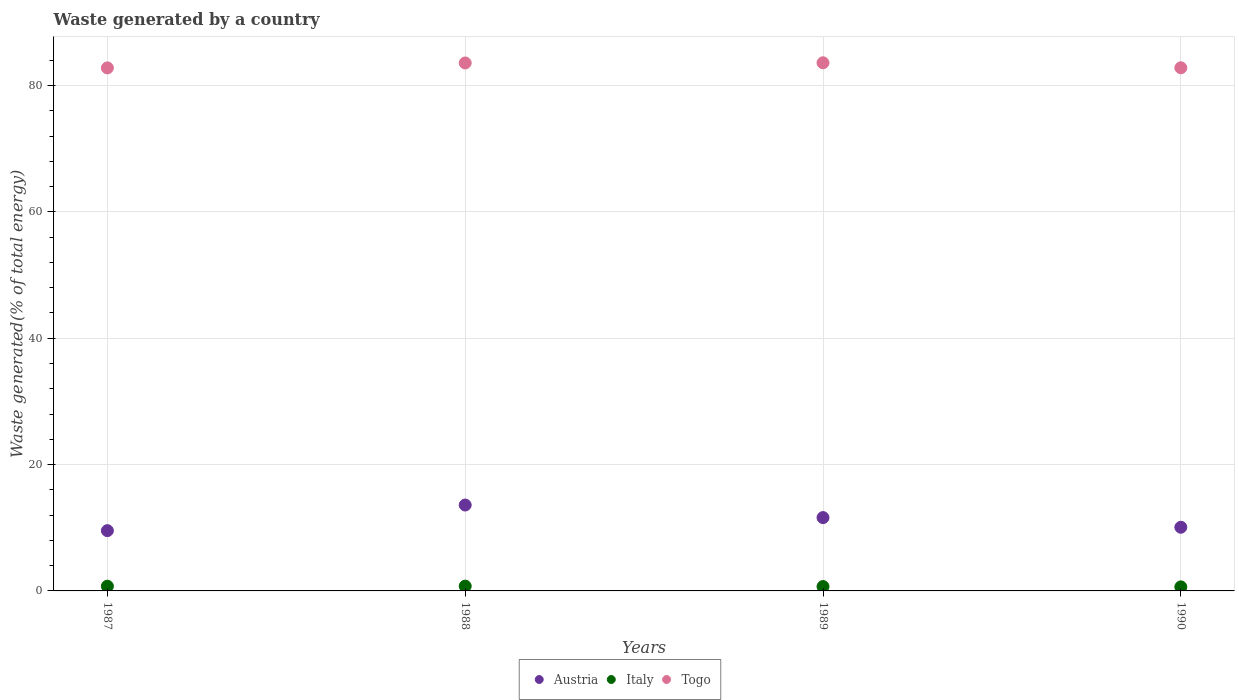How many different coloured dotlines are there?
Offer a very short reply. 3. What is the total waste generated in Austria in 1990?
Your answer should be compact. 10.08. Across all years, what is the maximum total waste generated in Austria?
Your answer should be very brief. 13.6. Across all years, what is the minimum total waste generated in Togo?
Your answer should be very brief. 82.79. In which year was the total waste generated in Austria minimum?
Your response must be concise. 1987. What is the total total waste generated in Italy in the graph?
Give a very brief answer. 2.84. What is the difference between the total waste generated in Italy in 1988 and that in 1989?
Your answer should be very brief. 0.07. What is the difference between the total waste generated in Austria in 1988 and the total waste generated in Italy in 1987?
Offer a very short reply. 12.85. What is the average total waste generated in Austria per year?
Provide a short and direct response. 11.21. In the year 1987, what is the difference between the total waste generated in Italy and total waste generated in Togo?
Provide a short and direct response. -82.05. What is the ratio of the total waste generated in Togo in 1987 to that in 1988?
Offer a terse response. 0.99. What is the difference between the highest and the second highest total waste generated in Italy?
Offer a terse response. 0.01. What is the difference between the highest and the lowest total waste generated in Togo?
Your answer should be compact. 0.81. Is it the case that in every year, the sum of the total waste generated in Austria and total waste generated in Italy  is greater than the total waste generated in Togo?
Provide a succinct answer. No. Is the total waste generated in Italy strictly greater than the total waste generated in Togo over the years?
Offer a terse response. No. Where does the legend appear in the graph?
Provide a succinct answer. Bottom center. How many legend labels are there?
Provide a short and direct response. 3. How are the legend labels stacked?
Provide a succinct answer. Horizontal. What is the title of the graph?
Your response must be concise. Waste generated by a country. Does "Guam" appear as one of the legend labels in the graph?
Your answer should be very brief. No. What is the label or title of the Y-axis?
Offer a terse response. Waste generated(% of total energy). What is the Waste generated(% of total energy) in Austria in 1987?
Provide a succinct answer. 9.54. What is the Waste generated(% of total energy) of Italy in 1987?
Your answer should be compact. 0.74. What is the Waste generated(% of total energy) of Togo in 1987?
Keep it short and to the point. 82.79. What is the Waste generated(% of total energy) in Austria in 1988?
Your response must be concise. 13.6. What is the Waste generated(% of total energy) of Italy in 1988?
Ensure brevity in your answer.  0.76. What is the Waste generated(% of total energy) of Togo in 1988?
Ensure brevity in your answer.  83.57. What is the Waste generated(% of total energy) of Austria in 1989?
Offer a very short reply. 11.61. What is the Waste generated(% of total energy) of Italy in 1989?
Your response must be concise. 0.69. What is the Waste generated(% of total energy) of Togo in 1989?
Ensure brevity in your answer.  83.6. What is the Waste generated(% of total energy) of Austria in 1990?
Keep it short and to the point. 10.08. What is the Waste generated(% of total energy) in Italy in 1990?
Make the answer very short. 0.64. What is the Waste generated(% of total energy) of Togo in 1990?
Give a very brief answer. 82.81. Across all years, what is the maximum Waste generated(% of total energy) in Austria?
Offer a terse response. 13.6. Across all years, what is the maximum Waste generated(% of total energy) in Italy?
Ensure brevity in your answer.  0.76. Across all years, what is the maximum Waste generated(% of total energy) in Togo?
Provide a short and direct response. 83.6. Across all years, what is the minimum Waste generated(% of total energy) in Austria?
Keep it short and to the point. 9.54. Across all years, what is the minimum Waste generated(% of total energy) in Italy?
Provide a succinct answer. 0.64. Across all years, what is the minimum Waste generated(% of total energy) of Togo?
Make the answer very short. 82.79. What is the total Waste generated(% of total energy) in Austria in the graph?
Your answer should be compact. 44.82. What is the total Waste generated(% of total energy) of Italy in the graph?
Provide a short and direct response. 2.84. What is the total Waste generated(% of total energy) of Togo in the graph?
Offer a very short reply. 332.77. What is the difference between the Waste generated(% of total energy) of Austria in 1987 and that in 1988?
Your answer should be very brief. -4.06. What is the difference between the Waste generated(% of total energy) of Italy in 1987 and that in 1988?
Offer a very short reply. -0.01. What is the difference between the Waste generated(% of total energy) in Togo in 1987 and that in 1988?
Make the answer very short. -0.78. What is the difference between the Waste generated(% of total energy) of Austria in 1987 and that in 1989?
Keep it short and to the point. -2.07. What is the difference between the Waste generated(% of total energy) of Italy in 1987 and that in 1989?
Your answer should be very brief. 0.05. What is the difference between the Waste generated(% of total energy) in Togo in 1987 and that in 1989?
Your answer should be very brief. -0.81. What is the difference between the Waste generated(% of total energy) of Austria in 1987 and that in 1990?
Make the answer very short. -0.54. What is the difference between the Waste generated(% of total energy) of Italy in 1987 and that in 1990?
Provide a succinct answer. 0.1. What is the difference between the Waste generated(% of total energy) of Togo in 1987 and that in 1990?
Your answer should be compact. -0.02. What is the difference between the Waste generated(% of total energy) of Austria in 1988 and that in 1989?
Keep it short and to the point. 1.99. What is the difference between the Waste generated(% of total energy) in Italy in 1988 and that in 1989?
Ensure brevity in your answer.  0.07. What is the difference between the Waste generated(% of total energy) in Togo in 1988 and that in 1989?
Provide a succinct answer. -0.03. What is the difference between the Waste generated(% of total energy) in Austria in 1988 and that in 1990?
Give a very brief answer. 3.52. What is the difference between the Waste generated(% of total energy) of Italy in 1988 and that in 1990?
Your answer should be very brief. 0.12. What is the difference between the Waste generated(% of total energy) of Togo in 1988 and that in 1990?
Provide a succinct answer. 0.76. What is the difference between the Waste generated(% of total energy) in Austria in 1989 and that in 1990?
Provide a succinct answer. 1.53. What is the difference between the Waste generated(% of total energy) in Italy in 1989 and that in 1990?
Make the answer very short. 0.05. What is the difference between the Waste generated(% of total energy) in Togo in 1989 and that in 1990?
Offer a very short reply. 0.79. What is the difference between the Waste generated(% of total energy) in Austria in 1987 and the Waste generated(% of total energy) in Italy in 1988?
Provide a short and direct response. 8.78. What is the difference between the Waste generated(% of total energy) in Austria in 1987 and the Waste generated(% of total energy) in Togo in 1988?
Make the answer very short. -74.03. What is the difference between the Waste generated(% of total energy) of Italy in 1987 and the Waste generated(% of total energy) of Togo in 1988?
Offer a terse response. -82.82. What is the difference between the Waste generated(% of total energy) in Austria in 1987 and the Waste generated(% of total energy) in Italy in 1989?
Keep it short and to the point. 8.85. What is the difference between the Waste generated(% of total energy) in Austria in 1987 and the Waste generated(% of total energy) in Togo in 1989?
Offer a terse response. -74.06. What is the difference between the Waste generated(% of total energy) of Italy in 1987 and the Waste generated(% of total energy) of Togo in 1989?
Offer a very short reply. -82.85. What is the difference between the Waste generated(% of total energy) in Austria in 1987 and the Waste generated(% of total energy) in Italy in 1990?
Provide a succinct answer. 8.9. What is the difference between the Waste generated(% of total energy) of Austria in 1987 and the Waste generated(% of total energy) of Togo in 1990?
Offer a very short reply. -73.27. What is the difference between the Waste generated(% of total energy) of Italy in 1987 and the Waste generated(% of total energy) of Togo in 1990?
Your answer should be very brief. -82.06. What is the difference between the Waste generated(% of total energy) in Austria in 1988 and the Waste generated(% of total energy) in Italy in 1989?
Your response must be concise. 12.91. What is the difference between the Waste generated(% of total energy) in Austria in 1988 and the Waste generated(% of total energy) in Togo in 1989?
Ensure brevity in your answer.  -70. What is the difference between the Waste generated(% of total energy) of Italy in 1988 and the Waste generated(% of total energy) of Togo in 1989?
Your answer should be very brief. -82.84. What is the difference between the Waste generated(% of total energy) of Austria in 1988 and the Waste generated(% of total energy) of Italy in 1990?
Ensure brevity in your answer.  12.96. What is the difference between the Waste generated(% of total energy) in Austria in 1988 and the Waste generated(% of total energy) in Togo in 1990?
Provide a succinct answer. -69.21. What is the difference between the Waste generated(% of total energy) of Italy in 1988 and the Waste generated(% of total energy) of Togo in 1990?
Provide a succinct answer. -82.05. What is the difference between the Waste generated(% of total energy) in Austria in 1989 and the Waste generated(% of total energy) in Italy in 1990?
Give a very brief answer. 10.96. What is the difference between the Waste generated(% of total energy) of Austria in 1989 and the Waste generated(% of total energy) of Togo in 1990?
Your answer should be compact. -71.2. What is the difference between the Waste generated(% of total energy) of Italy in 1989 and the Waste generated(% of total energy) of Togo in 1990?
Offer a very short reply. -82.12. What is the average Waste generated(% of total energy) in Austria per year?
Offer a very short reply. 11.21. What is the average Waste generated(% of total energy) of Italy per year?
Your answer should be compact. 0.71. What is the average Waste generated(% of total energy) of Togo per year?
Offer a terse response. 83.19. In the year 1987, what is the difference between the Waste generated(% of total energy) of Austria and Waste generated(% of total energy) of Italy?
Offer a very short reply. 8.8. In the year 1987, what is the difference between the Waste generated(% of total energy) of Austria and Waste generated(% of total energy) of Togo?
Provide a short and direct response. -73.25. In the year 1987, what is the difference between the Waste generated(% of total energy) of Italy and Waste generated(% of total energy) of Togo?
Your answer should be compact. -82.05. In the year 1988, what is the difference between the Waste generated(% of total energy) in Austria and Waste generated(% of total energy) in Italy?
Provide a succinct answer. 12.84. In the year 1988, what is the difference between the Waste generated(% of total energy) in Austria and Waste generated(% of total energy) in Togo?
Your answer should be compact. -69.97. In the year 1988, what is the difference between the Waste generated(% of total energy) of Italy and Waste generated(% of total energy) of Togo?
Make the answer very short. -82.81. In the year 1989, what is the difference between the Waste generated(% of total energy) of Austria and Waste generated(% of total energy) of Italy?
Offer a terse response. 10.92. In the year 1989, what is the difference between the Waste generated(% of total energy) in Austria and Waste generated(% of total energy) in Togo?
Provide a short and direct response. -71.99. In the year 1989, what is the difference between the Waste generated(% of total energy) of Italy and Waste generated(% of total energy) of Togo?
Provide a short and direct response. -82.91. In the year 1990, what is the difference between the Waste generated(% of total energy) in Austria and Waste generated(% of total energy) in Italy?
Provide a succinct answer. 9.44. In the year 1990, what is the difference between the Waste generated(% of total energy) of Austria and Waste generated(% of total energy) of Togo?
Offer a terse response. -72.73. In the year 1990, what is the difference between the Waste generated(% of total energy) in Italy and Waste generated(% of total energy) in Togo?
Provide a short and direct response. -82.17. What is the ratio of the Waste generated(% of total energy) in Austria in 1987 to that in 1988?
Make the answer very short. 0.7. What is the ratio of the Waste generated(% of total energy) in Italy in 1987 to that in 1988?
Your answer should be very brief. 0.98. What is the ratio of the Waste generated(% of total energy) in Togo in 1987 to that in 1988?
Your response must be concise. 0.99. What is the ratio of the Waste generated(% of total energy) in Austria in 1987 to that in 1989?
Ensure brevity in your answer.  0.82. What is the ratio of the Waste generated(% of total energy) of Italy in 1987 to that in 1989?
Offer a terse response. 1.08. What is the ratio of the Waste generated(% of total energy) of Togo in 1987 to that in 1989?
Offer a terse response. 0.99. What is the ratio of the Waste generated(% of total energy) in Austria in 1987 to that in 1990?
Keep it short and to the point. 0.95. What is the ratio of the Waste generated(% of total energy) in Italy in 1987 to that in 1990?
Make the answer very short. 1.16. What is the ratio of the Waste generated(% of total energy) in Togo in 1987 to that in 1990?
Your answer should be very brief. 1. What is the ratio of the Waste generated(% of total energy) of Austria in 1988 to that in 1989?
Offer a very short reply. 1.17. What is the ratio of the Waste generated(% of total energy) of Italy in 1988 to that in 1989?
Provide a short and direct response. 1.1. What is the ratio of the Waste generated(% of total energy) in Austria in 1988 to that in 1990?
Offer a terse response. 1.35. What is the ratio of the Waste generated(% of total energy) in Italy in 1988 to that in 1990?
Ensure brevity in your answer.  1.18. What is the ratio of the Waste generated(% of total energy) in Togo in 1988 to that in 1990?
Your response must be concise. 1.01. What is the ratio of the Waste generated(% of total energy) of Austria in 1989 to that in 1990?
Your response must be concise. 1.15. What is the ratio of the Waste generated(% of total energy) in Italy in 1989 to that in 1990?
Provide a succinct answer. 1.08. What is the ratio of the Waste generated(% of total energy) in Togo in 1989 to that in 1990?
Offer a very short reply. 1.01. What is the difference between the highest and the second highest Waste generated(% of total energy) in Austria?
Your answer should be compact. 1.99. What is the difference between the highest and the second highest Waste generated(% of total energy) in Italy?
Your response must be concise. 0.01. What is the difference between the highest and the second highest Waste generated(% of total energy) of Togo?
Offer a very short reply. 0.03. What is the difference between the highest and the lowest Waste generated(% of total energy) of Austria?
Your answer should be very brief. 4.06. What is the difference between the highest and the lowest Waste generated(% of total energy) in Italy?
Provide a short and direct response. 0.12. What is the difference between the highest and the lowest Waste generated(% of total energy) of Togo?
Provide a succinct answer. 0.81. 